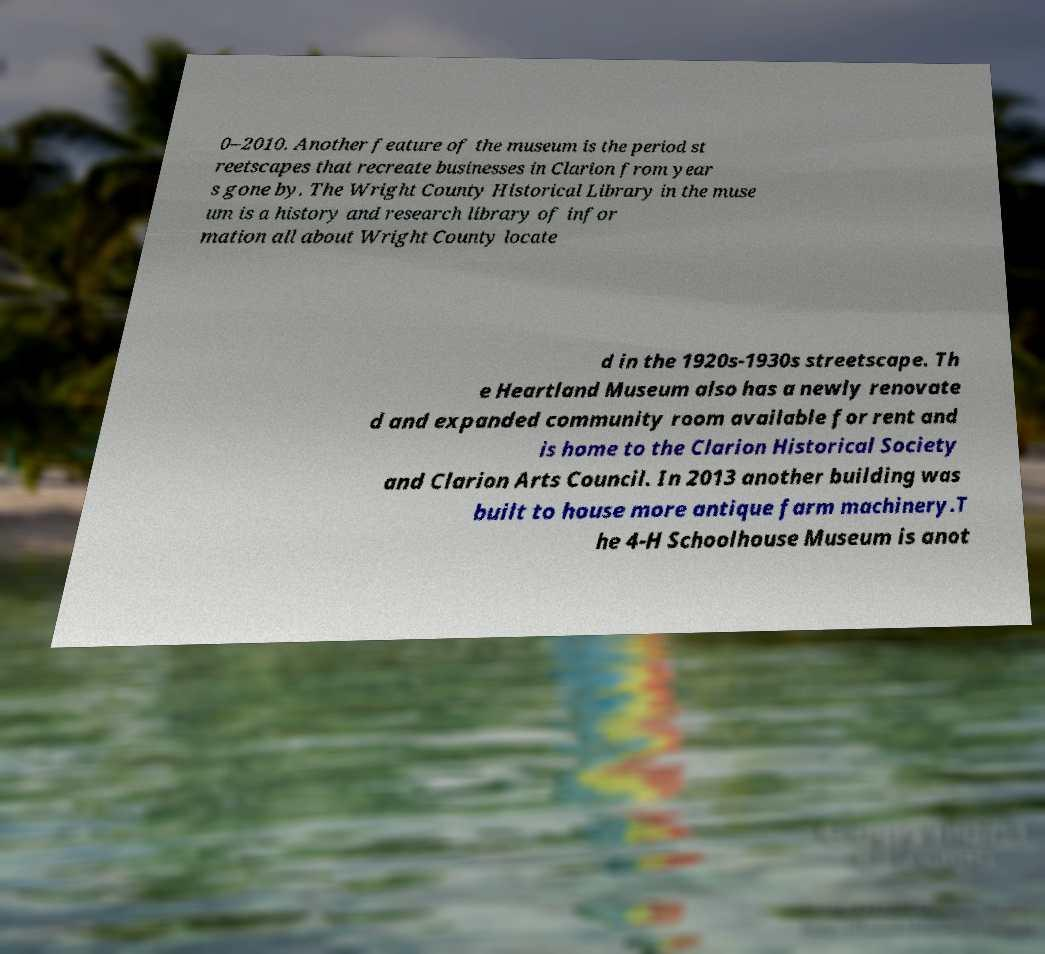Please read and relay the text visible in this image. What does it say? 0–2010. Another feature of the museum is the period st reetscapes that recreate businesses in Clarion from year s gone by. The Wright County Historical Library in the muse um is a history and research library of infor mation all about Wright County locate d in the 1920s-1930s streetscape. Th e Heartland Museum also has a newly renovate d and expanded community room available for rent and is home to the Clarion Historical Society and Clarion Arts Council. In 2013 another building was built to house more antique farm machinery.T he 4-H Schoolhouse Museum is anot 